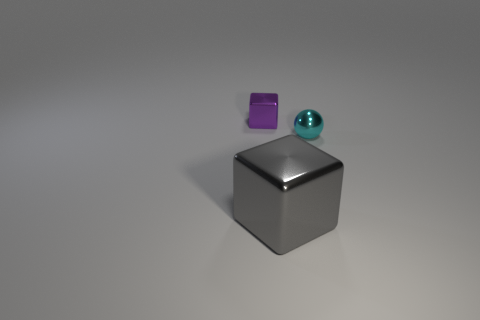Add 1 big gray matte objects. How many objects exist? 4 Add 3 tiny red matte spheres. How many tiny red matte spheres exist? 3 Subtract 0 brown spheres. How many objects are left? 3 Subtract all spheres. How many objects are left? 2 Subtract all tiny brown matte blocks. Subtract all cyan spheres. How many objects are left? 2 Add 3 large shiny cubes. How many large shiny cubes are left? 4 